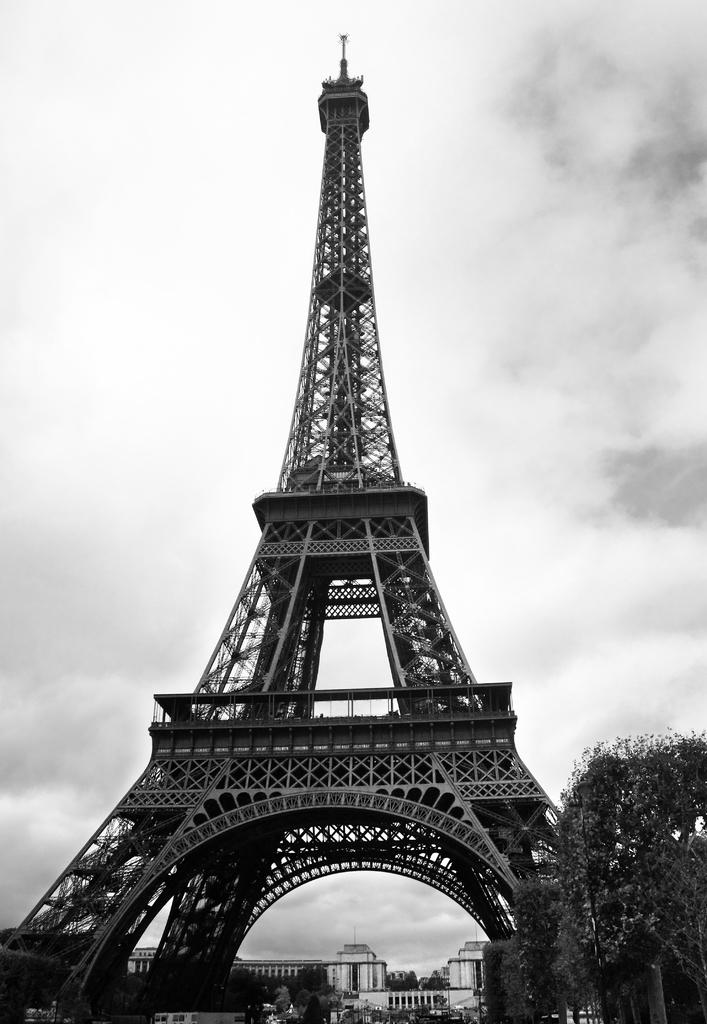What is the main structure in the center of the image? There is a tower in the center of the image. What can be seen in the background of the image? There are buildings and trees in the background of the image. Can you describe the tree on the right side of the image? There is a tree on the right side of the image. How would you describe the sky in the image? The sky is cloudy in the image. How many babies are sleeping in the bed in the image? There is no bed or babies present in the image. 